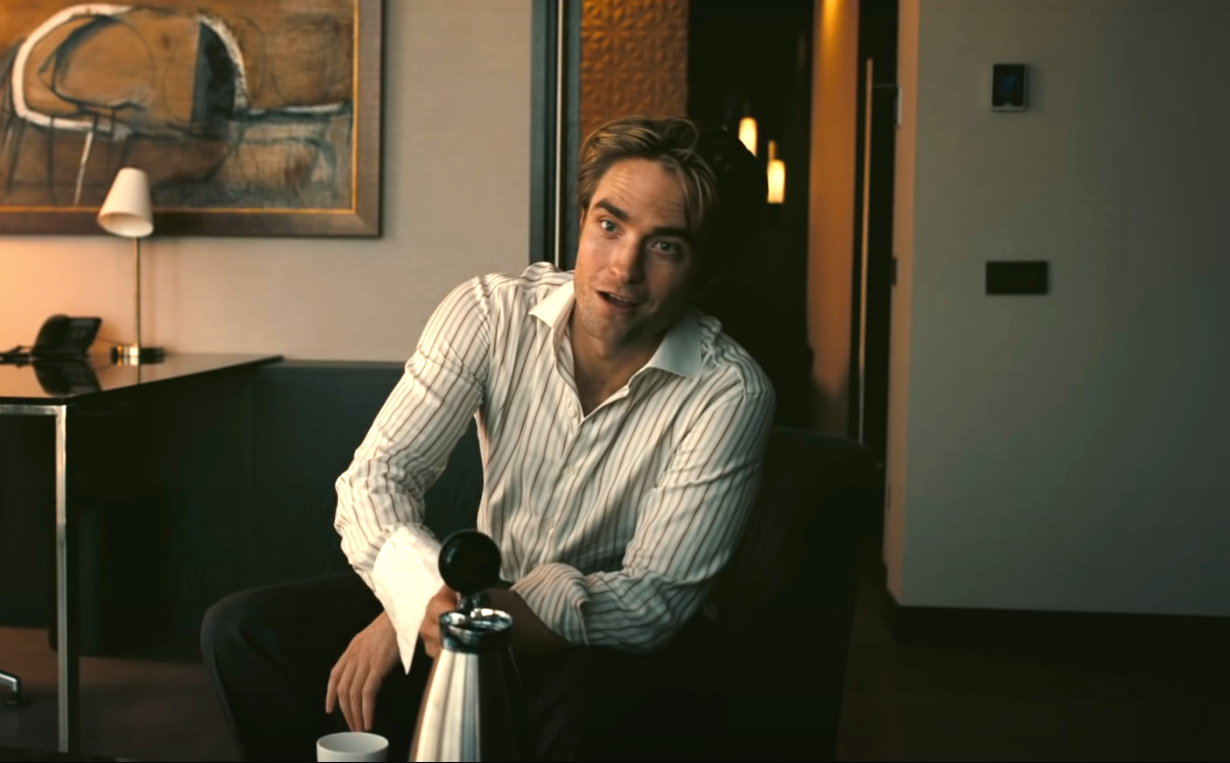If you could transform the scene into a fantastical setting, what would it look like? In a fantastical transformation, the living room could become a luxurious sky palace floating among the clouds. The black leather couch turns into a plush throne made of shimmering crystal, and the silver water pitcher transforms into a magical chalice that glows with an ethereal light. The walls are adorned with intricate murals depicting mythical creatures and enchanted forests. The painting behind him morphs into a window that offers a breathtaking view of a vibrant, otherworldly landscape with floating islands and cascading waterfalls. The man is now a wise sorcerer, deep in thought about the mysteries of his kingdom, with a serene and majestic aura surrounding him. 